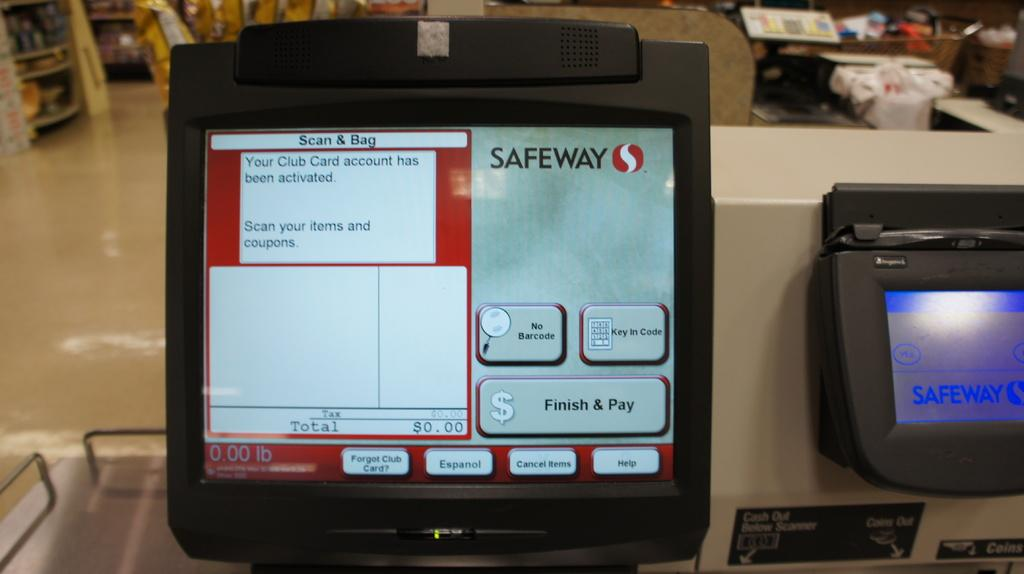<image>
Give a short and clear explanation of the subsequent image. checkout stand at safeway with monitor message that a club card account has been activated 